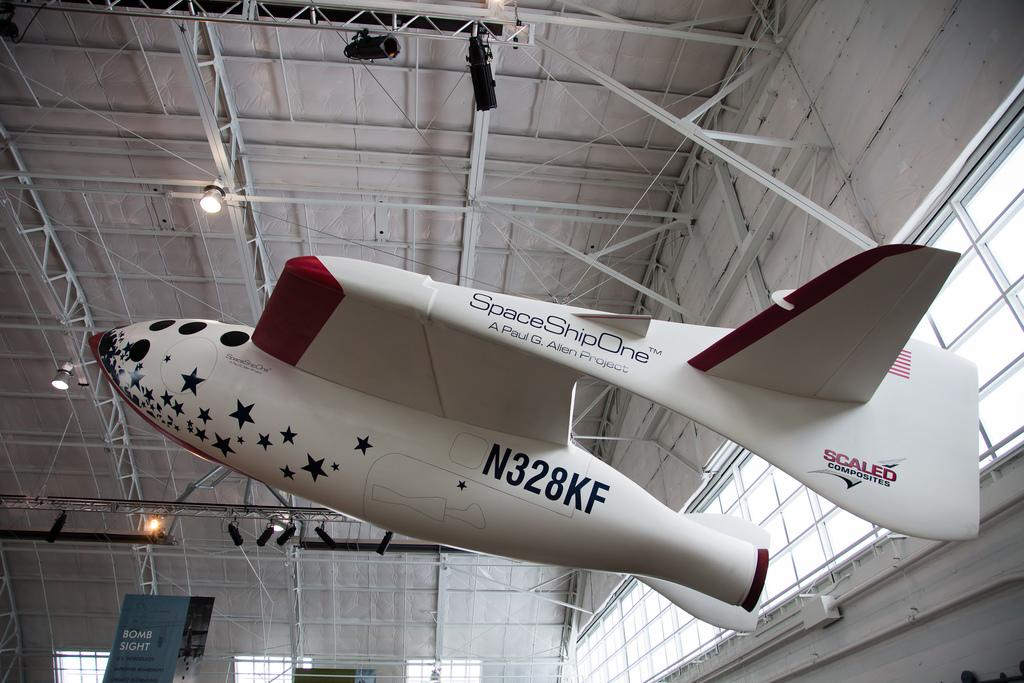<image>
Create a compact narrative representing the image presented. An aircraft hangs from a hangar ceiling. The aircraft has text painted on the side that reads SpaceShipOne A Paul G. Allen Project. 